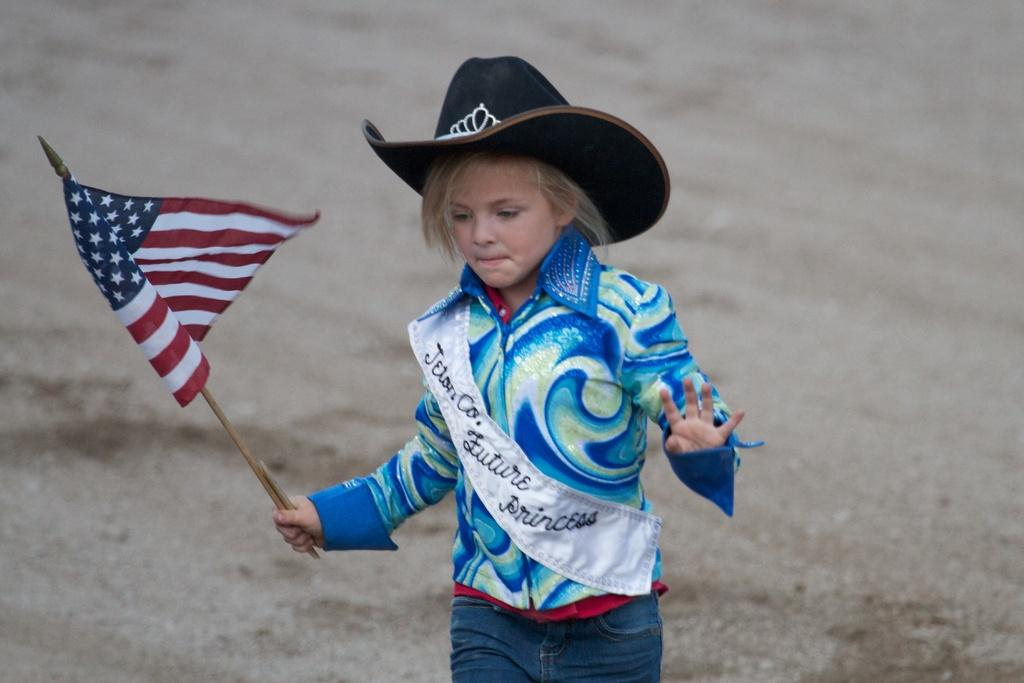What is the main subject of the image? There is a boy in the center of the image. What is the boy doing in the image? The boy is standing in the image. What is the boy holding in the image? The boy is holding a flag in the image. What type of canvas is the boy sitting on in the image? There is no canvas present in the image, and the boy is standing, not sitting. 